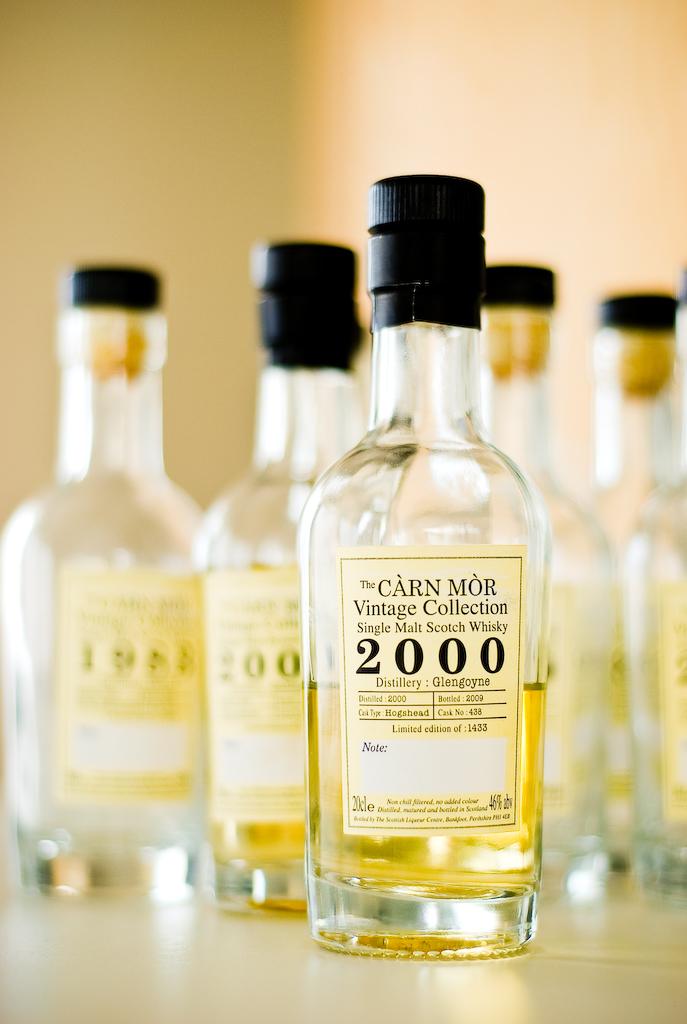What kind of collection is it?
Make the answer very short. Vintage. What is the year on this bottle?
Offer a very short reply. 2000. 